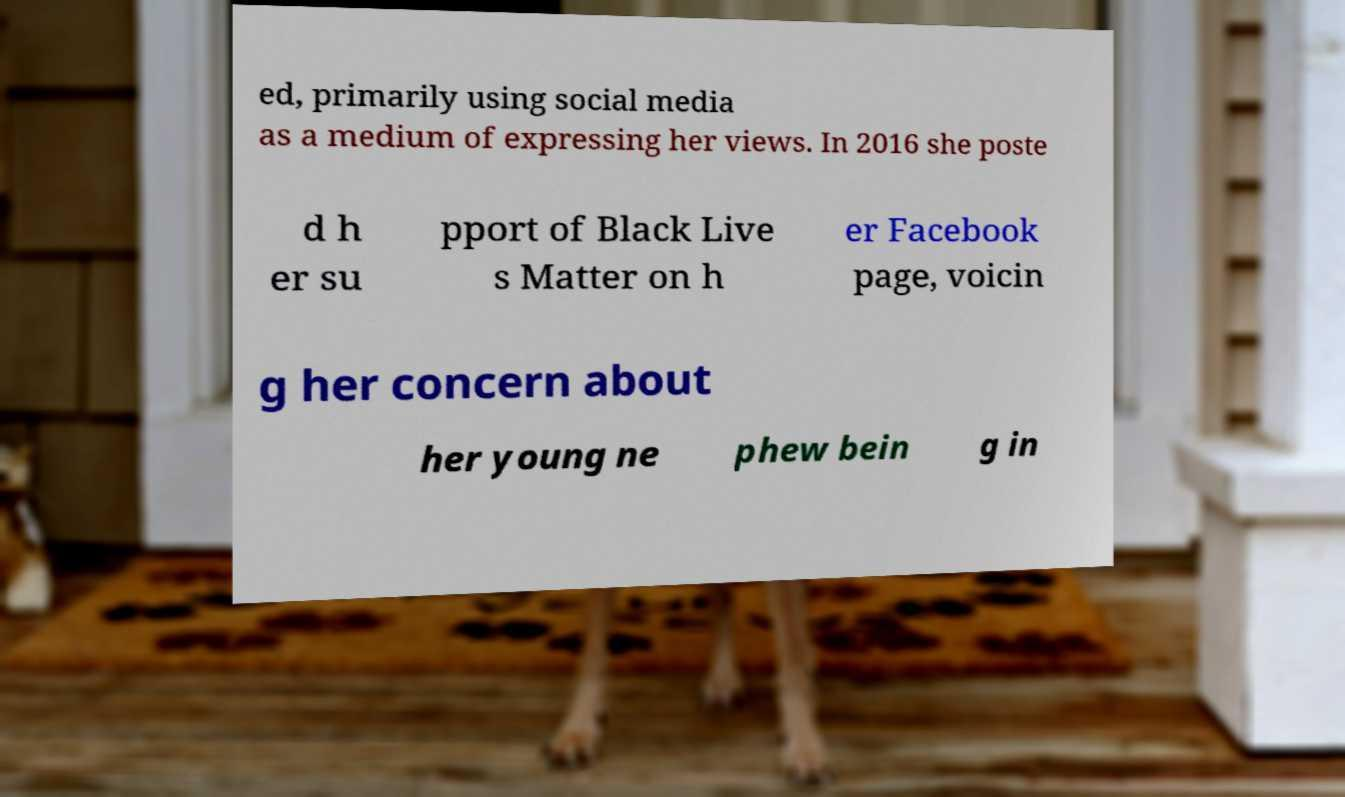Can you read and provide the text displayed in the image?This photo seems to have some interesting text. Can you extract and type it out for me? ed, primarily using social media as a medium of expressing her views. In 2016 she poste d h er su pport of Black Live s Matter on h er Facebook page, voicin g her concern about her young ne phew bein g in 